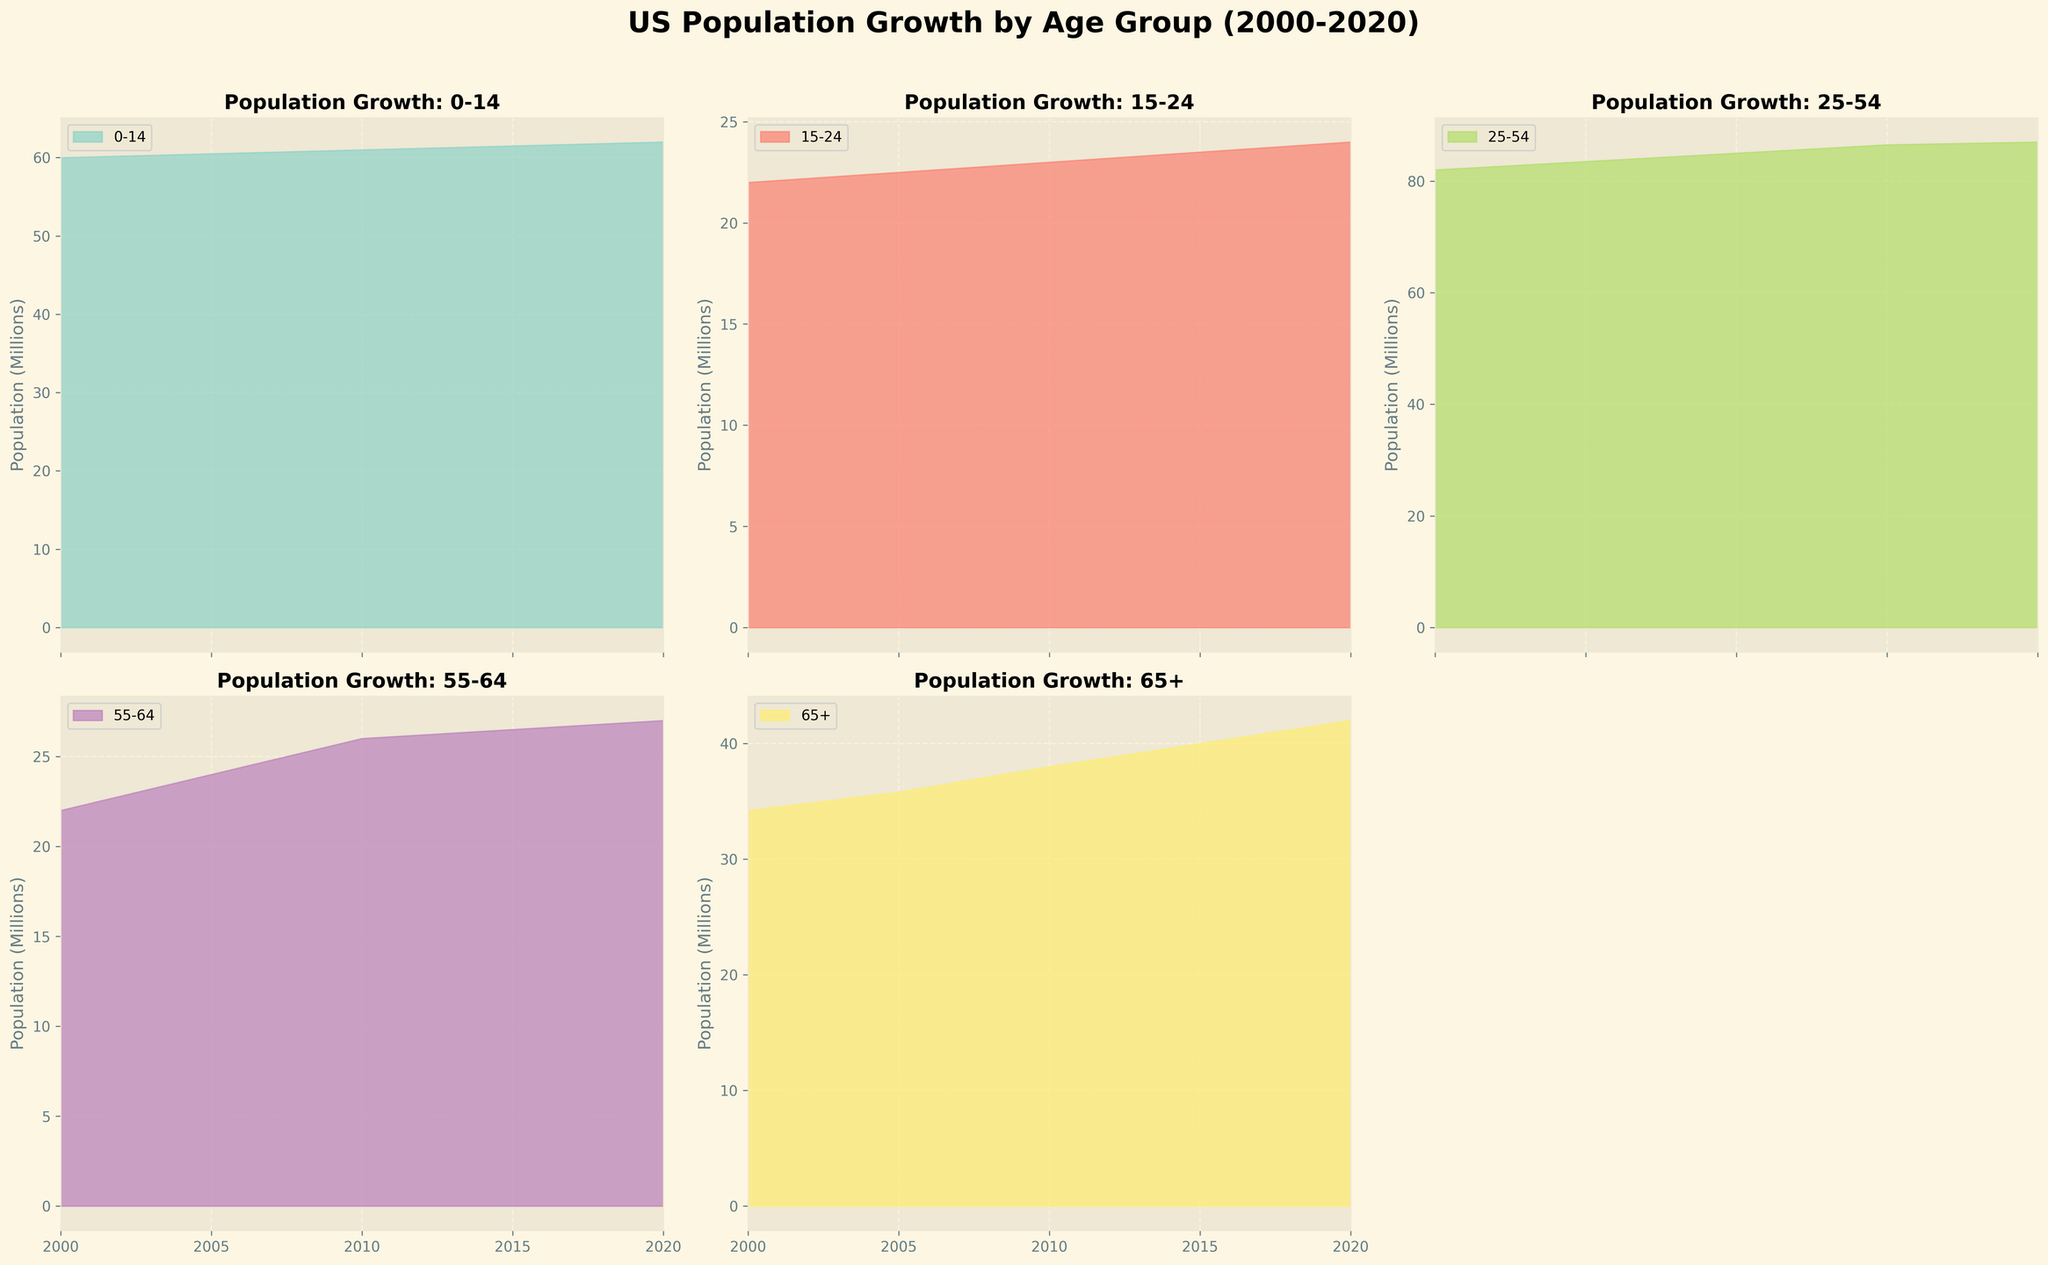what is the title of the figure? The title of the figure is found at the top center of the chart and it is in bold and large font size, indicating that it's the main heading of the entire visualization.
Answer: US Population Growth by Age Group (2000-2020) What is the population of the '0-14' age group in 2020? The subplot for the '0-14' age group displays its population data from 2000 to 2020. The value for the year 2020 is read directly from the figure.
Answer: 62,000,000 How many age groups are displayed in the figure? The figure divides the population into different age brackets, each with its own subplot. By counting the distinct subplots, we determine the total number of age groups depicted.
Answer: 5 Which age group witnessed the most significant population growth from 2000 to 2020? Comparing the endpoints (2000 and 2020) of each subplot, the '65+' age group shows the largest increase in area, indicating the most significant growth.
Answer: 65+ By how much did the population of the '55-64' age group increase between 2000 and 2020? By locating the 2000 and 2020 points on the '55-64' subplot, the population difference is calculated by subtracting the initial value from the final value. (27,000,000 - 22,000,000)
Answer: 5,000,000 Compare the population of the '25-54' and '65+' age groups in 2020. Which one is higher? In 2020, read the values from the subplots for '25-54' and '65+'. The population for '25-54' is 87,000,000 and for '65+' is 42,000,000.
Answer: 25-54 What color represents the '15-24' age group in the area chart? Each subplot is depicted with a distinct color. By identifying the color associated with the '15-24' subplot, its representation can be confirmed.
Answer: Various shades, e.g., blue-ish tone from the Set3 palette What is the average population of the '0-14' age group over the years 2000 to 2020? By adding up the population values for '0-14' age group for all years provided (60,000,000 + 60,500,000 + 61,000,000 + 61,500,000 + 62,000,000), then dividing by the number of years (5), we get the average.
Answer: 60,800,000 Which age group had the smallest population in 2000, and what was the value? By inspecting the 2000 population values across all subplots, '15-24' age group has the smallest value, which can be read directly from the plot.
Answer: 15-24; 22,000,000 